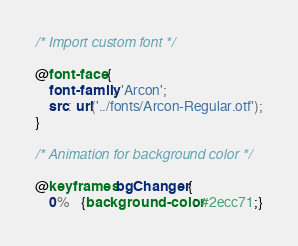<code> <loc_0><loc_0><loc_500><loc_500><_CSS_>/* Import custom font */

@font-face {
    font-family: 'Arcon';
    src: url('../fonts/Arcon-Regular.otf');
}

/* Animation for background color */

@keyframes bgChanger {
    0%   {background-color: #2ecc71;}</code> 